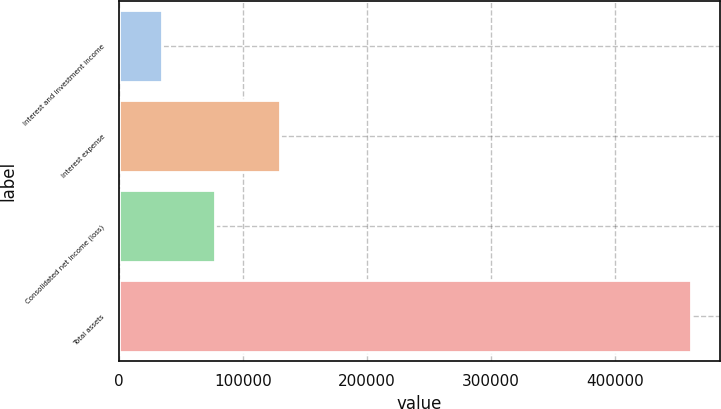<chart> <loc_0><loc_0><loc_500><loc_500><bar_chart><fcel>Interest and investment income<fcel>Interest expense<fcel>Consolidated net income (loss)<fcel>Total assets<nl><fcel>34303<fcel>129750<fcel>77023.2<fcel>461505<nl></chart> 